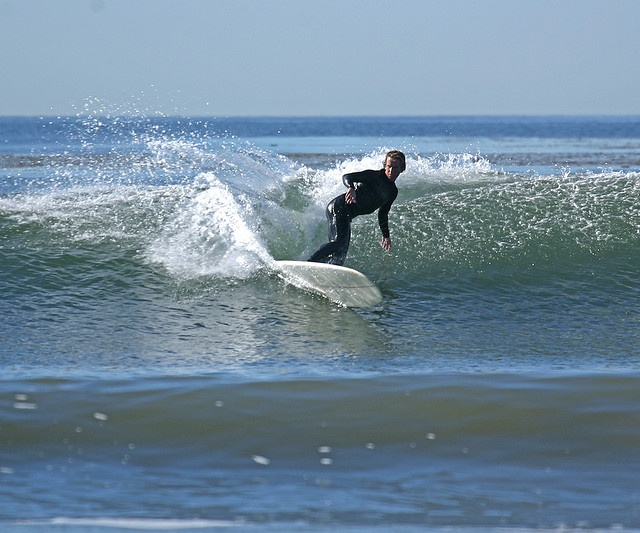Describe the objects in this image and their specific colors. I can see people in lightblue, black, gray, lightgray, and darkgray tones and surfboard in lightblue, darkgray, white, and gray tones in this image. 